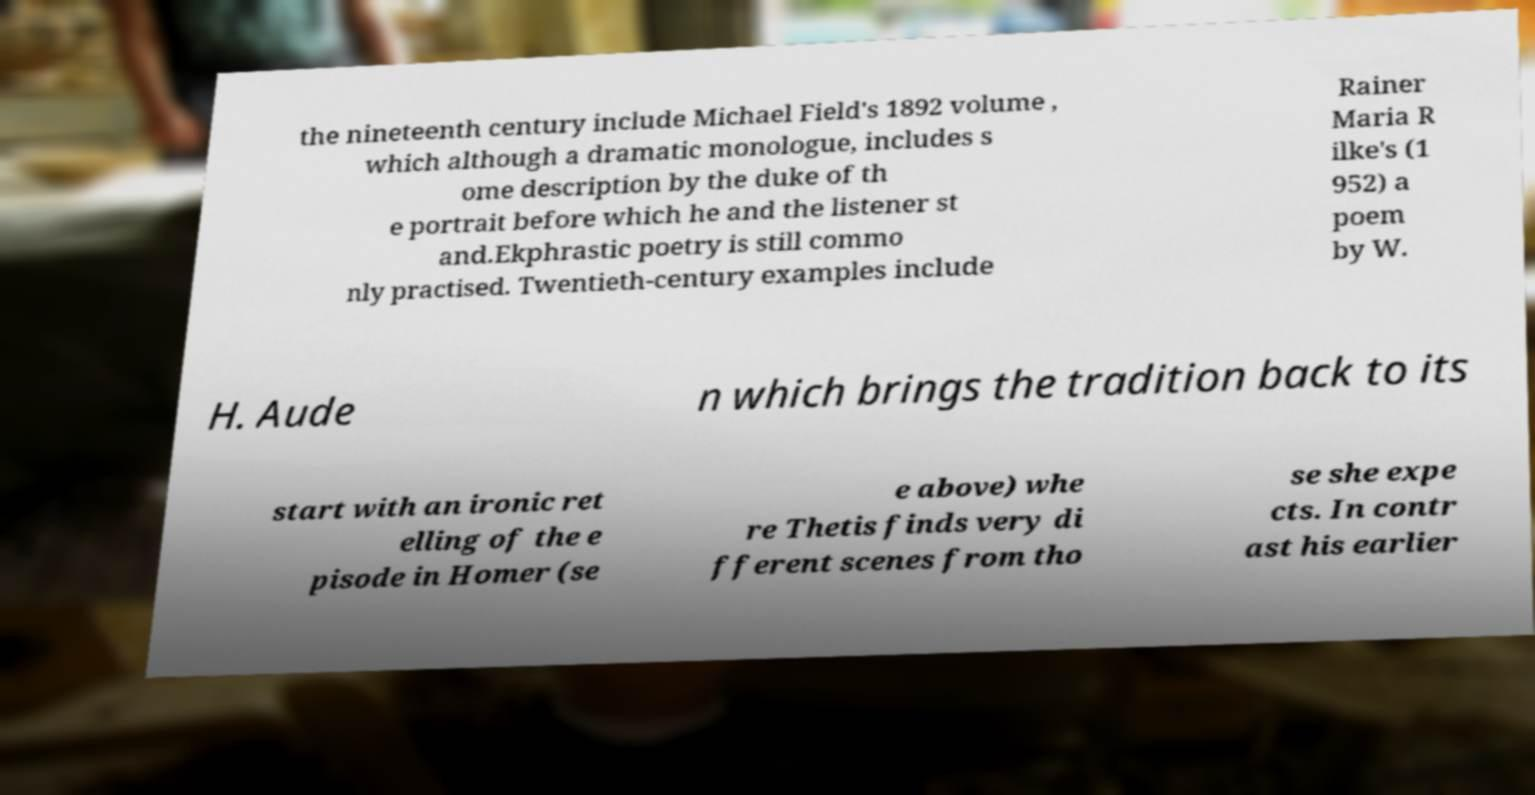Can you read and provide the text displayed in the image?This photo seems to have some interesting text. Can you extract and type it out for me? the nineteenth century include Michael Field's 1892 volume , which although a dramatic monologue, includes s ome description by the duke of th e portrait before which he and the listener st and.Ekphrastic poetry is still commo nly practised. Twentieth-century examples include Rainer Maria R ilke's (1 952) a poem by W. H. Aude n which brings the tradition back to its start with an ironic ret elling of the e pisode in Homer (se e above) whe re Thetis finds very di fferent scenes from tho se she expe cts. In contr ast his earlier 